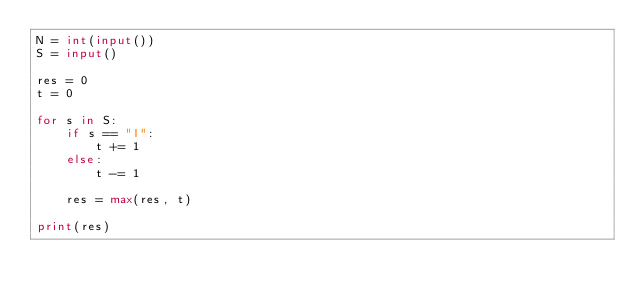<code> <loc_0><loc_0><loc_500><loc_500><_Python_>N = int(input())
S = input()

res = 0
t = 0

for s in S:
    if s == "I":
        t += 1
    else:
        t -= 1

    res = max(res, t)

print(res)</code> 